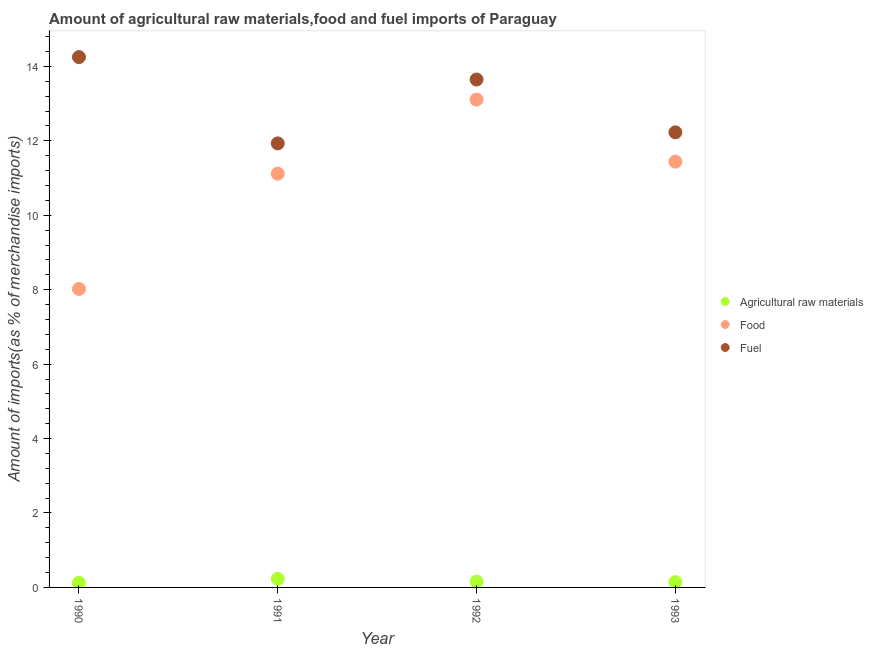How many different coloured dotlines are there?
Your response must be concise. 3. What is the percentage of food imports in 1993?
Offer a very short reply. 11.44. Across all years, what is the maximum percentage of food imports?
Give a very brief answer. 13.11. Across all years, what is the minimum percentage of fuel imports?
Provide a short and direct response. 11.93. In which year was the percentage of fuel imports maximum?
Ensure brevity in your answer.  1990. What is the total percentage of raw materials imports in the graph?
Ensure brevity in your answer.  0.65. What is the difference between the percentage of fuel imports in 1991 and that in 1993?
Your response must be concise. -0.3. What is the difference between the percentage of fuel imports in 1993 and the percentage of food imports in 1991?
Ensure brevity in your answer.  1.11. What is the average percentage of raw materials imports per year?
Make the answer very short. 0.16. In the year 1992, what is the difference between the percentage of fuel imports and percentage of raw materials imports?
Ensure brevity in your answer.  13.49. In how many years, is the percentage of raw materials imports greater than 11.2 %?
Keep it short and to the point. 0. What is the ratio of the percentage of food imports in 1990 to that in 1992?
Your response must be concise. 0.61. Is the percentage of food imports in 1990 less than that in 1993?
Your response must be concise. Yes. Is the difference between the percentage of food imports in 1992 and 1993 greater than the difference between the percentage of raw materials imports in 1992 and 1993?
Your answer should be very brief. Yes. What is the difference between the highest and the second highest percentage of food imports?
Offer a terse response. 1.67. What is the difference between the highest and the lowest percentage of raw materials imports?
Offer a terse response. 0.11. Is it the case that in every year, the sum of the percentage of raw materials imports and percentage of food imports is greater than the percentage of fuel imports?
Keep it short and to the point. No. Is the percentage of raw materials imports strictly greater than the percentage of fuel imports over the years?
Provide a succinct answer. No. Is the percentage of food imports strictly less than the percentage of fuel imports over the years?
Make the answer very short. Yes. How many years are there in the graph?
Offer a very short reply. 4. What is the difference between two consecutive major ticks on the Y-axis?
Your answer should be very brief. 2. Are the values on the major ticks of Y-axis written in scientific E-notation?
Ensure brevity in your answer.  No. Where does the legend appear in the graph?
Ensure brevity in your answer.  Center right. How are the legend labels stacked?
Offer a terse response. Vertical. What is the title of the graph?
Offer a very short reply. Amount of agricultural raw materials,food and fuel imports of Paraguay. Does "Infant(female)" appear as one of the legend labels in the graph?
Keep it short and to the point. No. What is the label or title of the X-axis?
Give a very brief answer. Year. What is the label or title of the Y-axis?
Offer a very short reply. Amount of imports(as % of merchandise imports). What is the Amount of imports(as % of merchandise imports) in Agricultural raw materials in 1990?
Your answer should be compact. 0.13. What is the Amount of imports(as % of merchandise imports) of Food in 1990?
Offer a terse response. 8.02. What is the Amount of imports(as % of merchandise imports) in Fuel in 1990?
Your answer should be very brief. 14.25. What is the Amount of imports(as % of merchandise imports) of Agricultural raw materials in 1991?
Give a very brief answer. 0.23. What is the Amount of imports(as % of merchandise imports) in Food in 1991?
Your answer should be compact. 11.12. What is the Amount of imports(as % of merchandise imports) in Fuel in 1991?
Your answer should be compact. 11.93. What is the Amount of imports(as % of merchandise imports) of Agricultural raw materials in 1992?
Make the answer very short. 0.15. What is the Amount of imports(as % of merchandise imports) of Food in 1992?
Give a very brief answer. 13.11. What is the Amount of imports(as % of merchandise imports) in Fuel in 1992?
Keep it short and to the point. 13.65. What is the Amount of imports(as % of merchandise imports) of Agricultural raw materials in 1993?
Give a very brief answer. 0.14. What is the Amount of imports(as % of merchandise imports) of Food in 1993?
Offer a terse response. 11.44. What is the Amount of imports(as % of merchandise imports) of Fuel in 1993?
Give a very brief answer. 12.23. Across all years, what is the maximum Amount of imports(as % of merchandise imports) of Agricultural raw materials?
Give a very brief answer. 0.23. Across all years, what is the maximum Amount of imports(as % of merchandise imports) in Food?
Ensure brevity in your answer.  13.11. Across all years, what is the maximum Amount of imports(as % of merchandise imports) in Fuel?
Offer a very short reply. 14.25. Across all years, what is the minimum Amount of imports(as % of merchandise imports) of Agricultural raw materials?
Ensure brevity in your answer.  0.13. Across all years, what is the minimum Amount of imports(as % of merchandise imports) in Food?
Keep it short and to the point. 8.02. Across all years, what is the minimum Amount of imports(as % of merchandise imports) of Fuel?
Ensure brevity in your answer.  11.93. What is the total Amount of imports(as % of merchandise imports) of Agricultural raw materials in the graph?
Provide a short and direct response. 0.65. What is the total Amount of imports(as % of merchandise imports) in Food in the graph?
Make the answer very short. 43.69. What is the total Amount of imports(as % of merchandise imports) in Fuel in the graph?
Your answer should be compact. 52.06. What is the difference between the Amount of imports(as % of merchandise imports) in Agricultural raw materials in 1990 and that in 1991?
Provide a succinct answer. -0.11. What is the difference between the Amount of imports(as % of merchandise imports) of Food in 1990 and that in 1991?
Give a very brief answer. -3.1. What is the difference between the Amount of imports(as % of merchandise imports) in Fuel in 1990 and that in 1991?
Keep it short and to the point. 2.32. What is the difference between the Amount of imports(as % of merchandise imports) of Agricultural raw materials in 1990 and that in 1992?
Ensure brevity in your answer.  -0.03. What is the difference between the Amount of imports(as % of merchandise imports) in Food in 1990 and that in 1992?
Your response must be concise. -5.09. What is the difference between the Amount of imports(as % of merchandise imports) in Fuel in 1990 and that in 1992?
Offer a terse response. 0.6. What is the difference between the Amount of imports(as % of merchandise imports) in Agricultural raw materials in 1990 and that in 1993?
Give a very brief answer. -0.02. What is the difference between the Amount of imports(as % of merchandise imports) in Food in 1990 and that in 1993?
Give a very brief answer. -3.42. What is the difference between the Amount of imports(as % of merchandise imports) in Fuel in 1990 and that in 1993?
Offer a terse response. 2.02. What is the difference between the Amount of imports(as % of merchandise imports) of Agricultural raw materials in 1991 and that in 1992?
Offer a very short reply. 0.08. What is the difference between the Amount of imports(as % of merchandise imports) in Food in 1991 and that in 1992?
Your answer should be compact. -1.99. What is the difference between the Amount of imports(as % of merchandise imports) of Fuel in 1991 and that in 1992?
Provide a succinct answer. -1.72. What is the difference between the Amount of imports(as % of merchandise imports) in Agricultural raw materials in 1991 and that in 1993?
Provide a succinct answer. 0.09. What is the difference between the Amount of imports(as % of merchandise imports) in Food in 1991 and that in 1993?
Your response must be concise. -0.32. What is the difference between the Amount of imports(as % of merchandise imports) in Fuel in 1991 and that in 1993?
Provide a succinct answer. -0.3. What is the difference between the Amount of imports(as % of merchandise imports) in Agricultural raw materials in 1992 and that in 1993?
Ensure brevity in your answer.  0.01. What is the difference between the Amount of imports(as % of merchandise imports) of Food in 1992 and that in 1993?
Provide a succinct answer. 1.67. What is the difference between the Amount of imports(as % of merchandise imports) in Fuel in 1992 and that in 1993?
Ensure brevity in your answer.  1.42. What is the difference between the Amount of imports(as % of merchandise imports) of Agricultural raw materials in 1990 and the Amount of imports(as % of merchandise imports) of Food in 1991?
Offer a terse response. -10.99. What is the difference between the Amount of imports(as % of merchandise imports) of Agricultural raw materials in 1990 and the Amount of imports(as % of merchandise imports) of Fuel in 1991?
Your answer should be very brief. -11.81. What is the difference between the Amount of imports(as % of merchandise imports) of Food in 1990 and the Amount of imports(as % of merchandise imports) of Fuel in 1991?
Offer a terse response. -3.91. What is the difference between the Amount of imports(as % of merchandise imports) in Agricultural raw materials in 1990 and the Amount of imports(as % of merchandise imports) in Food in 1992?
Your answer should be very brief. -12.98. What is the difference between the Amount of imports(as % of merchandise imports) of Agricultural raw materials in 1990 and the Amount of imports(as % of merchandise imports) of Fuel in 1992?
Make the answer very short. -13.52. What is the difference between the Amount of imports(as % of merchandise imports) of Food in 1990 and the Amount of imports(as % of merchandise imports) of Fuel in 1992?
Offer a terse response. -5.63. What is the difference between the Amount of imports(as % of merchandise imports) in Agricultural raw materials in 1990 and the Amount of imports(as % of merchandise imports) in Food in 1993?
Your response must be concise. -11.32. What is the difference between the Amount of imports(as % of merchandise imports) in Agricultural raw materials in 1990 and the Amount of imports(as % of merchandise imports) in Fuel in 1993?
Provide a short and direct response. -12.1. What is the difference between the Amount of imports(as % of merchandise imports) in Food in 1990 and the Amount of imports(as % of merchandise imports) in Fuel in 1993?
Give a very brief answer. -4.21. What is the difference between the Amount of imports(as % of merchandise imports) of Agricultural raw materials in 1991 and the Amount of imports(as % of merchandise imports) of Food in 1992?
Your response must be concise. -12.88. What is the difference between the Amount of imports(as % of merchandise imports) of Agricultural raw materials in 1991 and the Amount of imports(as % of merchandise imports) of Fuel in 1992?
Offer a very short reply. -13.42. What is the difference between the Amount of imports(as % of merchandise imports) of Food in 1991 and the Amount of imports(as % of merchandise imports) of Fuel in 1992?
Provide a succinct answer. -2.53. What is the difference between the Amount of imports(as % of merchandise imports) of Agricultural raw materials in 1991 and the Amount of imports(as % of merchandise imports) of Food in 1993?
Provide a succinct answer. -11.21. What is the difference between the Amount of imports(as % of merchandise imports) in Agricultural raw materials in 1991 and the Amount of imports(as % of merchandise imports) in Fuel in 1993?
Your answer should be very brief. -12. What is the difference between the Amount of imports(as % of merchandise imports) of Food in 1991 and the Amount of imports(as % of merchandise imports) of Fuel in 1993?
Your response must be concise. -1.11. What is the difference between the Amount of imports(as % of merchandise imports) of Agricultural raw materials in 1992 and the Amount of imports(as % of merchandise imports) of Food in 1993?
Offer a very short reply. -11.29. What is the difference between the Amount of imports(as % of merchandise imports) in Agricultural raw materials in 1992 and the Amount of imports(as % of merchandise imports) in Fuel in 1993?
Offer a very short reply. -12.07. What is the difference between the Amount of imports(as % of merchandise imports) of Food in 1992 and the Amount of imports(as % of merchandise imports) of Fuel in 1993?
Your answer should be compact. 0.88. What is the average Amount of imports(as % of merchandise imports) of Agricultural raw materials per year?
Provide a short and direct response. 0.16. What is the average Amount of imports(as % of merchandise imports) in Food per year?
Your answer should be very brief. 10.92. What is the average Amount of imports(as % of merchandise imports) in Fuel per year?
Provide a succinct answer. 13.02. In the year 1990, what is the difference between the Amount of imports(as % of merchandise imports) in Agricultural raw materials and Amount of imports(as % of merchandise imports) in Food?
Offer a terse response. -7.9. In the year 1990, what is the difference between the Amount of imports(as % of merchandise imports) in Agricultural raw materials and Amount of imports(as % of merchandise imports) in Fuel?
Keep it short and to the point. -14.13. In the year 1990, what is the difference between the Amount of imports(as % of merchandise imports) of Food and Amount of imports(as % of merchandise imports) of Fuel?
Provide a succinct answer. -6.23. In the year 1991, what is the difference between the Amount of imports(as % of merchandise imports) of Agricultural raw materials and Amount of imports(as % of merchandise imports) of Food?
Your answer should be very brief. -10.89. In the year 1991, what is the difference between the Amount of imports(as % of merchandise imports) in Agricultural raw materials and Amount of imports(as % of merchandise imports) in Fuel?
Provide a succinct answer. -11.7. In the year 1991, what is the difference between the Amount of imports(as % of merchandise imports) of Food and Amount of imports(as % of merchandise imports) of Fuel?
Ensure brevity in your answer.  -0.81. In the year 1992, what is the difference between the Amount of imports(as % of merchandise imports) in Agricultural raw materials and Amount of imports(as % of merchandise imports) in Food?
Ensure brevity in your answer.  -12.96. In the year 1992, what is the difference between the Amount of imports(as % of merchandise imports) of Agricultural raw materials and Amount of imports(as % of merchandise imports) of Fuel?
Your answer should be very brief. -13.49. In the year 1992, what is the difference between the Amount of imports(as % of merchandise imports) of Food and Amount of imports(as % of merchandise imports) of Fuel?
Offer a terse response. -0.54. In the year 1993, what is the difference between the Amount of imports(as % of merchandise imports) in Agricultural raw materials and Amount of imports(as % of merchandise imports) in Food?
Offer a terse response. -11.3. In the year 1993, what is the difference between the Amount of imports(as % of merchandise imports) of Agricultural raw materials and Amount of imports(as % of merchandise imports) of Fuel?
Your answer should be very brief. -12.09. In the year 1993, what is the difference between the Amount of imports(as % of merchandise imports) in Food and Amount of imports(as % of merchandise imports) in Fuel?
Provide a succinct answer. -0.79. What is the ratio of the Amount of imports(as % of merchandise imports) in Agricultural raw materials in 1990 to that in 1991?
Offer a terse response. 0.54. What is the ratio of the Amount of imports(as % of merchandise imports) in Food in 1990 to that in 1991?
Your answer should be very brief. 0.72. What is the ratio of the Amount of imports(as % of merchandise imports) in Fuel in 1990 to that in 1991?
Keep it short and to the point. 1.19. What is the ratio of the Amount of imports(as % of merchandise imports) of Agricultural raw materials in 1990 to that in 1992?
Offer a terse response. 0.81. What is the ratio of the Amount of imports(as % of merchandise imports) of Food in 1990 to that in 1992?
Offer a very short reply. 0.61. What is the ratio of the Amount of imports(as % of merchandise imports) in Fuel in 1990 to that in 1992?
Offer a terse response. 1.04. What is the ratio of the Amount of imports(as % of merchandise imports) of Agricultural raw materials in 1990 to that in 1993?
Give a very brief answer. 0.88. What is the ratio of the Amount of imports(as % of merchandise imports) in Food in 1990 to that in 1993?
Keep it short and to the point. 0.7. What is the ratio of the Amount of imports(as % of merchandise imports) in Fuel in 1990 to that in 1993?
Offer a very short reply. 1.17. What is the ratio of the Amount of imports(as % of merchandise imports) of Agricultural raw materials in 1991 to that in 1992?
Ensure brevity in your answer.  1.49. What is the ratio of the Amount of imports(as % of merchandise imports) of Food in 1991 to that in 1992?
Your response must be concise. 0.85. What is the ratio of the Amount of imports(as % of merchandise imports) in Fuel in 1991 to that in 1992?
Your response must be concise. 0.87. What is the ratio of the Amount of imports(as % of merchandise imports) in Agricultural raw materials in 1991 to that in 1993?
Your answer should be very brief. 1.63. What is the ratio of the Amount of imports(as % of merchandise imports) of Food in 1991 to that in 1993?
Keep it short and to the point. 0.97. What is the ratio of the Amount of imports(as % of merchandise imports) in Fuel in 1991 to that in 1993?
Ensure brevity in your answer.  0.98. What is the ratio of the Amount of imports(as % of merchandise imports) of Agricultural raw materials in 1992 to that in 1993?
Your answer should be very brief. 1.09. What is the ratio of the Amount of imports(as % of merchandise imports) of Food in 1992 to that in 1993?
Your answer should be very brief. 1.15. What is the ratio of the Amount of imports(as % of merchandise imports) in Fuel in 1992 to that in 1993?
Offer a very short reply. 1.12. What is the difference between the highest and the second highest Amount of imports(as % of merchandise imports) in Agricultural raw materials?
Offer a very short reply. 0.08. What is the difference between the highest and the second highest Amount of imports(as % of merchandise imports) in Food?
Your response must be concise. 1.67. What is the difference between the highest and the second highest Amount of imports(as % of merchandise imports) in Fuel?
Ensure brevity in your answer.  0.6. What is the difference between the highest and the lowest Amount of imports(as % of merchandise imports) of Agricultural raw materials?
Your answer should be compact. 0.11. What is the difference between the highest and the lowest Amount of imports(as % of merchandise imports) in Food?
Offer a terse response. 5.09. What is the difference between the highest and the lowest Amount of imports(as % of merchandise imports) in Fuel?
Your response must be concise. 2.32. 